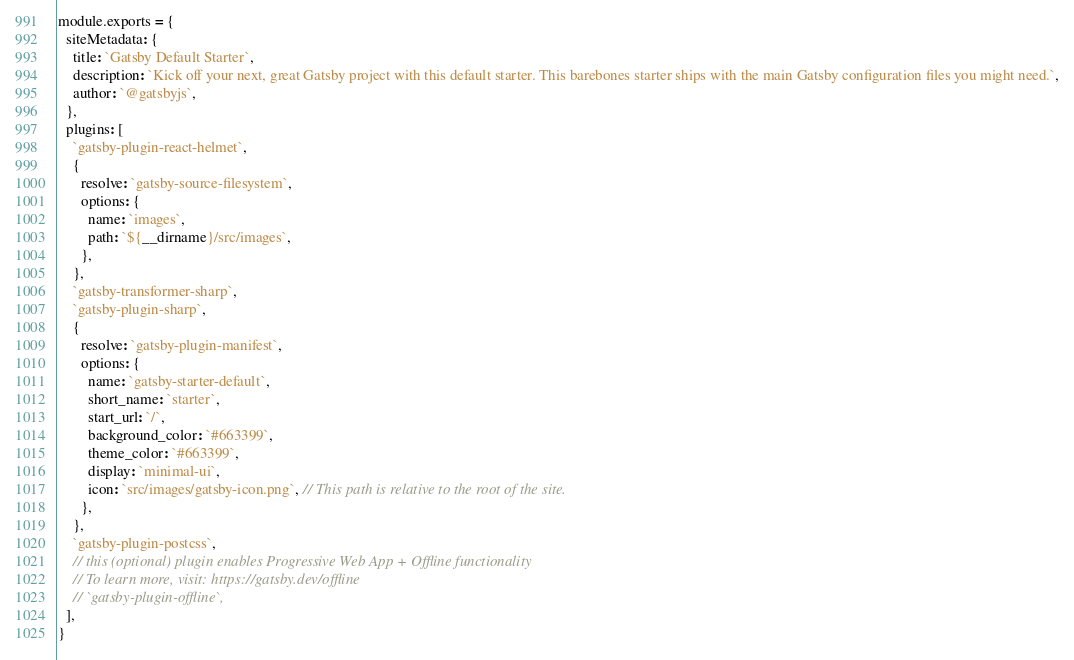<code> <loc_0><loc_0><loc_500><loc_500><_JavaScript_>module.exports = {
  siteMetadata: {
    title: `Gatsby Default Starter`,
    description: `Kick off your next, great Gatsby project with this default starter. This barebones starter ships with the main Gatsby configuration files you might need.`,
    author: `@gatsbyjs`,
  },
  plugins: [
    `gatsby-plugin-react-helmet`,
    {
      resolve: `gatsby-source-filesystem`,
      options: {
        name: `images`,
        path: `${__dirname}/src/images`,
      },
    },
    `gatsby-transformer-sharp`,
    `gatsby-plugin-sharp`,
    {
      resolve: `gatsby-plugin-manifest`,
      options: {
        name: `gatsby-starter-default`,
        short_name: `starter`,
        start_url: `/`,
        background_color: `#663399`,
        theme_color: `#663399`,
        display: `minimal-ui`,
        icon: `src/images/gatsby-icon.png`, // This path is relative to the root of the site.
      },
    },
    `gatsby-plugin-postcss`,
    // this (optional) plugin enables Progressive Web App + Offline functionality
    // To learn more, visit: https://gatsby.dev/offline
    // `gatsby-plugin-offline`,
  ],
}
</code> 